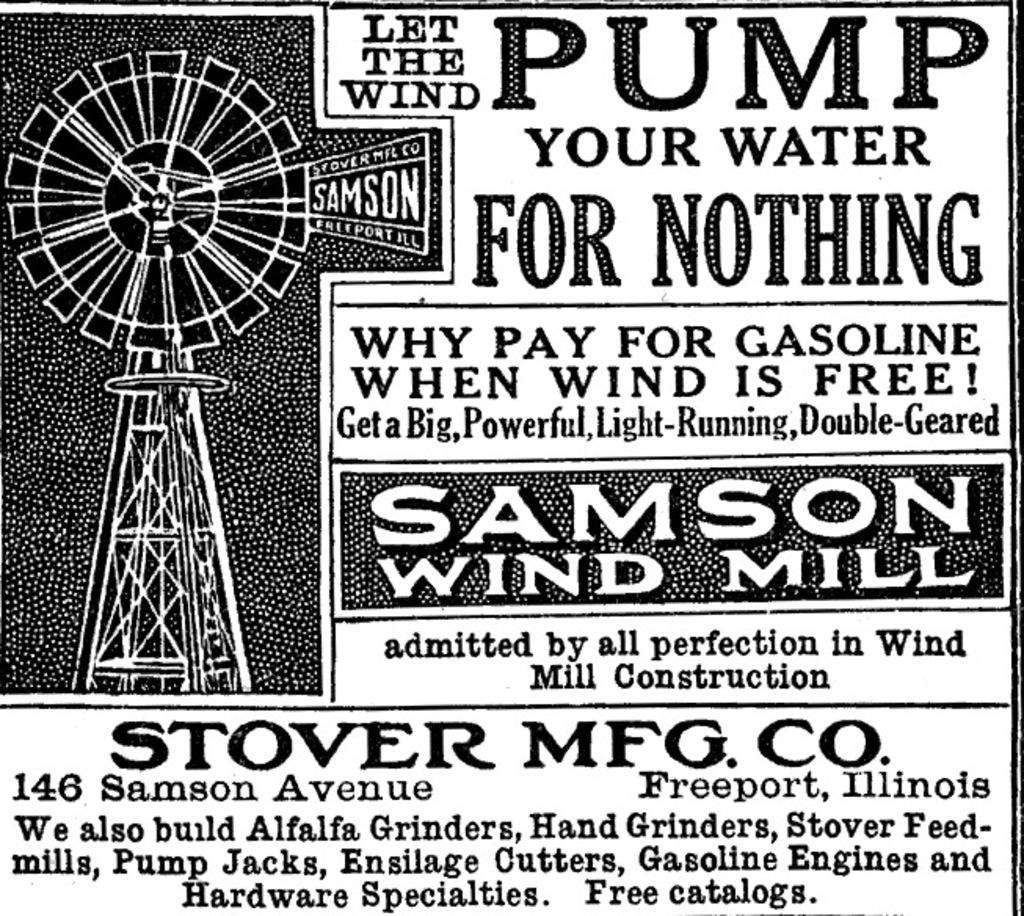<image>
Give a short and clear explanation of the subsequent image. a very old fashion newspaper advertisement for pumping water 